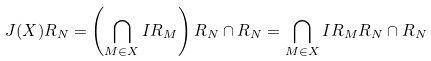Convert formula to latex. <formula><loc_0><loc_0><loc_500><loc_500>J ( X ) R _ { N } = \left ( \bigcap _ { M \in X } I R _ { M } \right ) R _ { N } \cap R _ { N } = \bigcap _ { M \in X } I R _ { M } R _ { N } \cap R _ { N }</formula> 